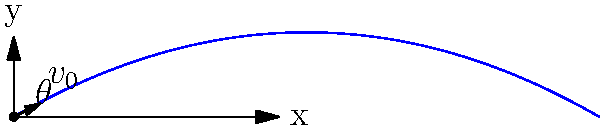You're testing a new air rifle with a muzzle velocity of 50 m/s. If you aim the rifle at an angle of 30° above the horizontal, what is the maximum height reached by the pellet? To find the maximum height reached by the pellet, we can follow these steps:

1) The vertical component of the initial velocity is given by:
   $v_{0y} = v_0 \sin \theta = 50 \sin 30° = 25$ m/s

2) The time to reach the maximum height is when the vertical velocity becomes zero:
   $t_{max} = \frac{v_{0y}}{g}$, where $g$ is the acceleration due to gravity (9.8 m/s²)
   $t_{max} = \frac{25}{9.8} = 2.55$ seconds

3) The maximum height can be calculated using the equation:
   $h_{max} = v_{0y} t_{max} - \frac{1}{2} g t_{max}^2$

4) Substituting the values:
   $h_{max} = 25 \times 2.55 - \frac{1}{2} \times 9.8 \times 2.55^2$
   $h_{max} = 63.75 - 31.87 = 31.88$ meters

Therefore, the maximum height reached by the pellet is approximately 31.88 meters.
Answer: 31.88 meters 